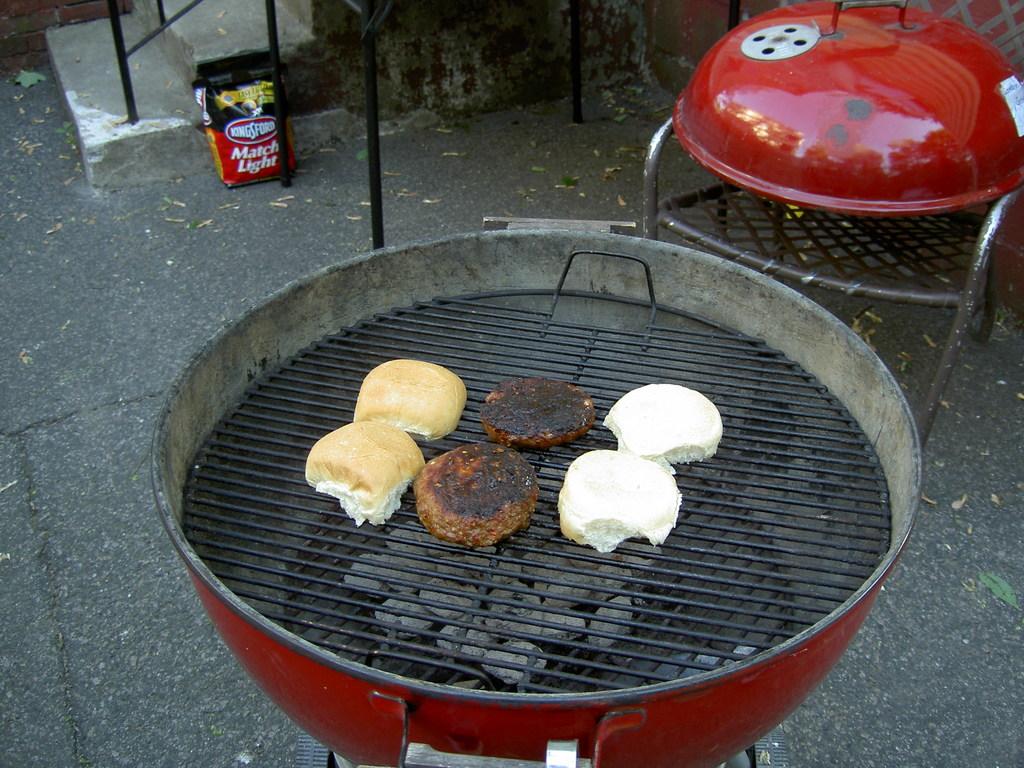Is the charcoal lit?
Your answer should be very brief. Answering does not require reading text in the image. What's the name of the charcoal?
Give a very brief answer. Kingsford. 